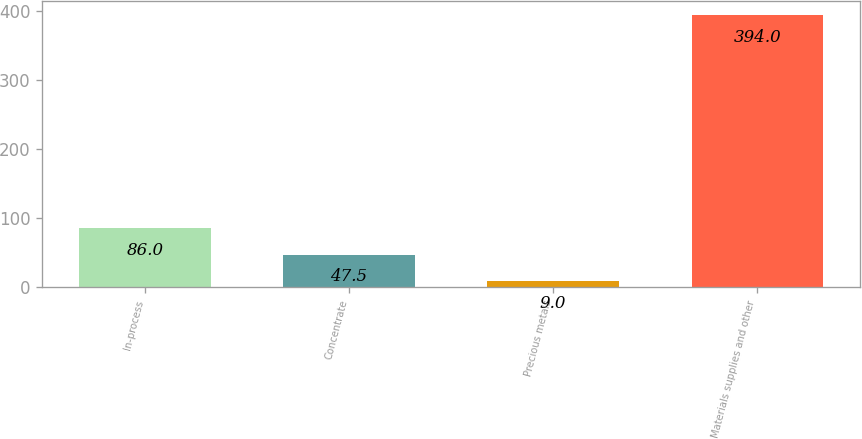Convert chart to OTSL. <chart><loc_0><loc_0><loc_500><loc_500><bar_chart><fcel>In-process<fcel>Concentrate<fcel>Precious metals<fcel>Materials supplies and other<nl><fcel>86<fcel>47.5<fcel>9<fcel>394<nl></chart> 